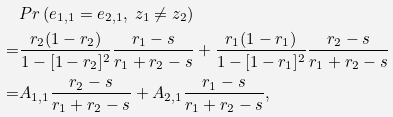<formula> <loc_0><loc_0><loc_500><loc_500>& P r \left ( e _ { 1 , 1 } = e _ { 2 , 1 } , \ z _ { 1 } \neq z _ { 2 } \right ) \\ = & \frac { r _ { 2 } ( 1 - r _ { 2 } ) } { 1 - [ 1 - r _ { 2 } ] ^ { 2 } } \frac { r _ { 1 } - s } { r _ { 1 } + r _ { 2 } - s } + \frac { r _ { 1 } ( 1 - r _ { 1 } ) } { 1 - [ 1 - r _ { 1 } ] ^ { 2 } } \frac { r _ { 2 } - s } { r _ { 1 } + r _ { 2 } - s } \\ = & A _ { 1 , 1 } \frac { r _ { 2 } - s } { r _ { 1 } + r _ { 2 } - s } + A _ { 2 , 1 } \frac { r _ { 1 } - s } { r _ { 1 } + r _ { 2 } - s } ,</formula> 